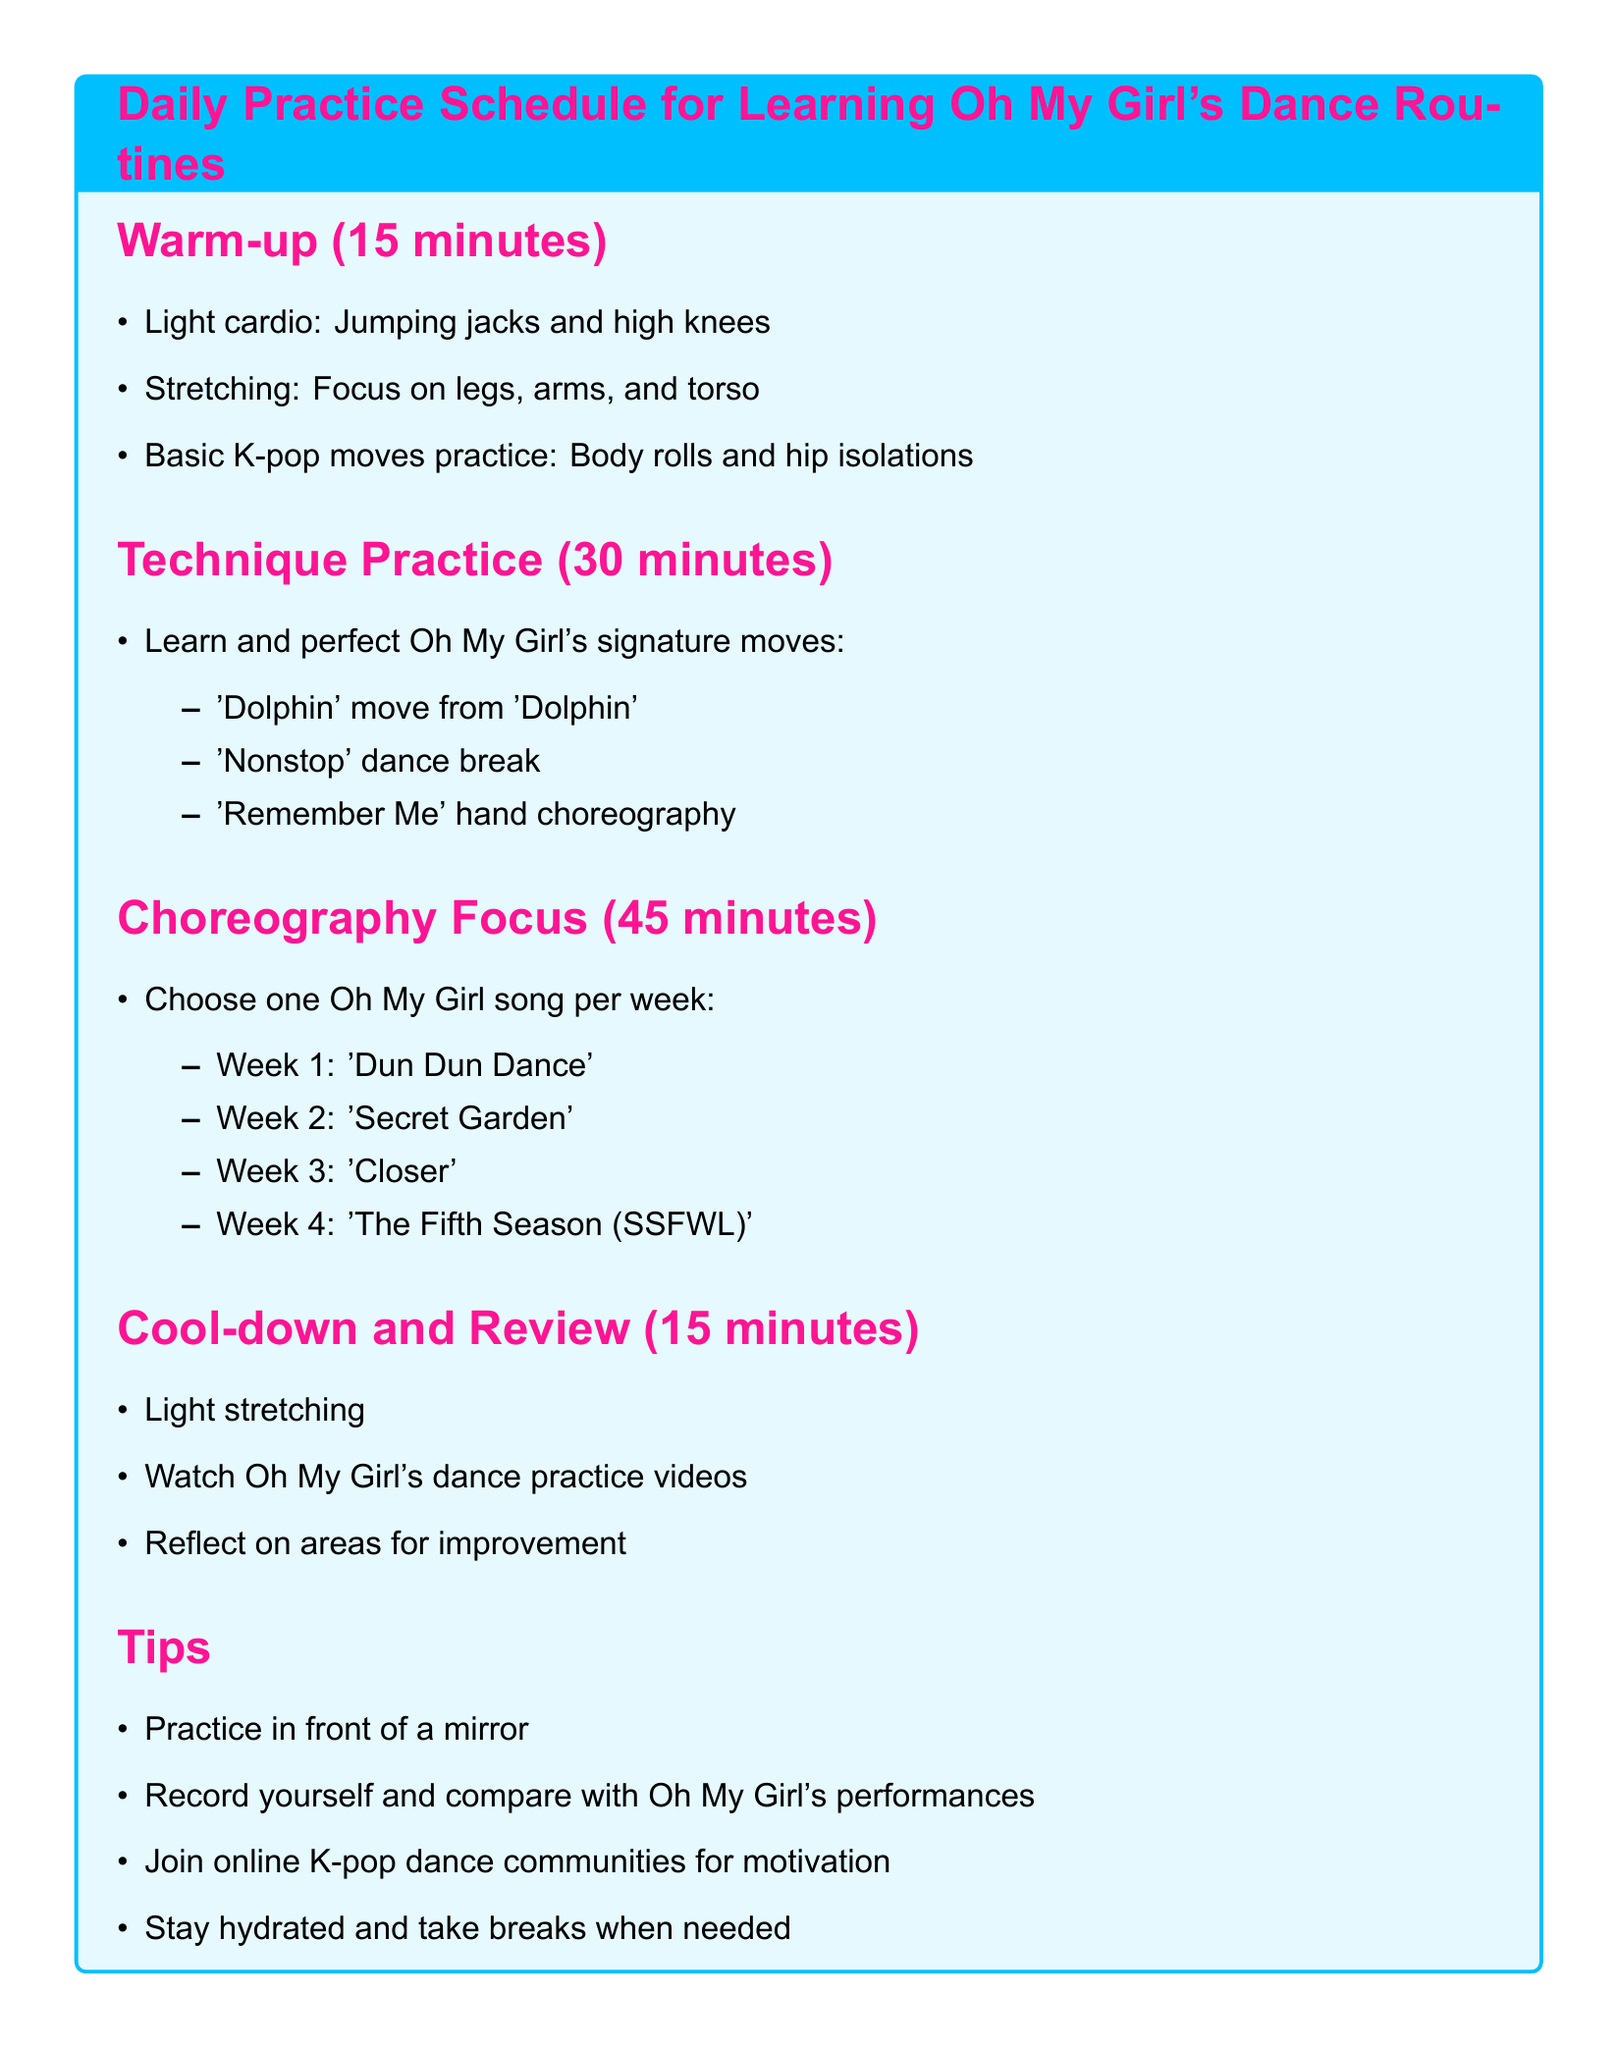What is the duration of the warm-up session? The warm-up session duration is explicitly mentioned in the document.
Answer: 15 minutes How many signature moves from Oh My Girl are mentioned? The document lists specific signature moves to learn, indicating the number.
Answer: 3 What is the focus for the first week of choreography practice? The document states the song for each week, identifying the first week's focus.
Answer: Dun Dun Dance What should you do during the cool-down phase? The document outlines actions to take during the cool-down, providing necessary information.
Answer: Light stretching What is one tip for practicing? The document contains various tips for improving practice efficiency, which are directly listed.
Answer: Practice in front of a mirror Which Oh My Girl song is scheduled for Week 3? The list of songs for each week includes the title for Week 3, which is specified in the document.
Answer: Closer What types of movements are practiced during the warm-up? The document specifies the types of movements included in the warm-up section; it's a direct retrieval of this information.
Answer: Light cardio How long is the total practice schedule? By adding together the durations of all sections, we can determine the total for the practice schedule.
Answer: 105 minutes Which community activity is suggested in the tips? The tips section suggests joining specific groups for motivation, indicating the social aspect of practice.
Answer: Online K-pop dance communities 